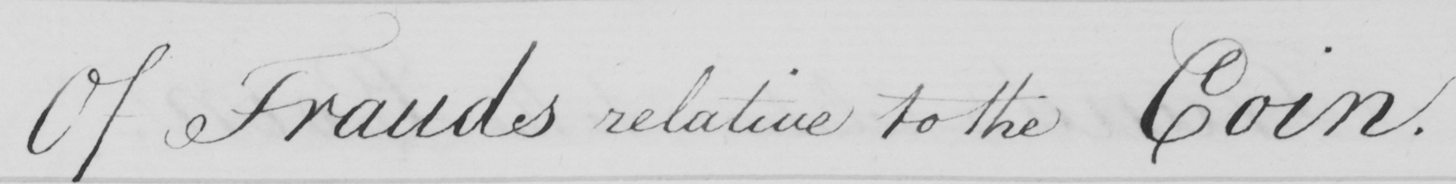Can you tell me what this handwritten text says? Of Frauds relative to the Coin . 